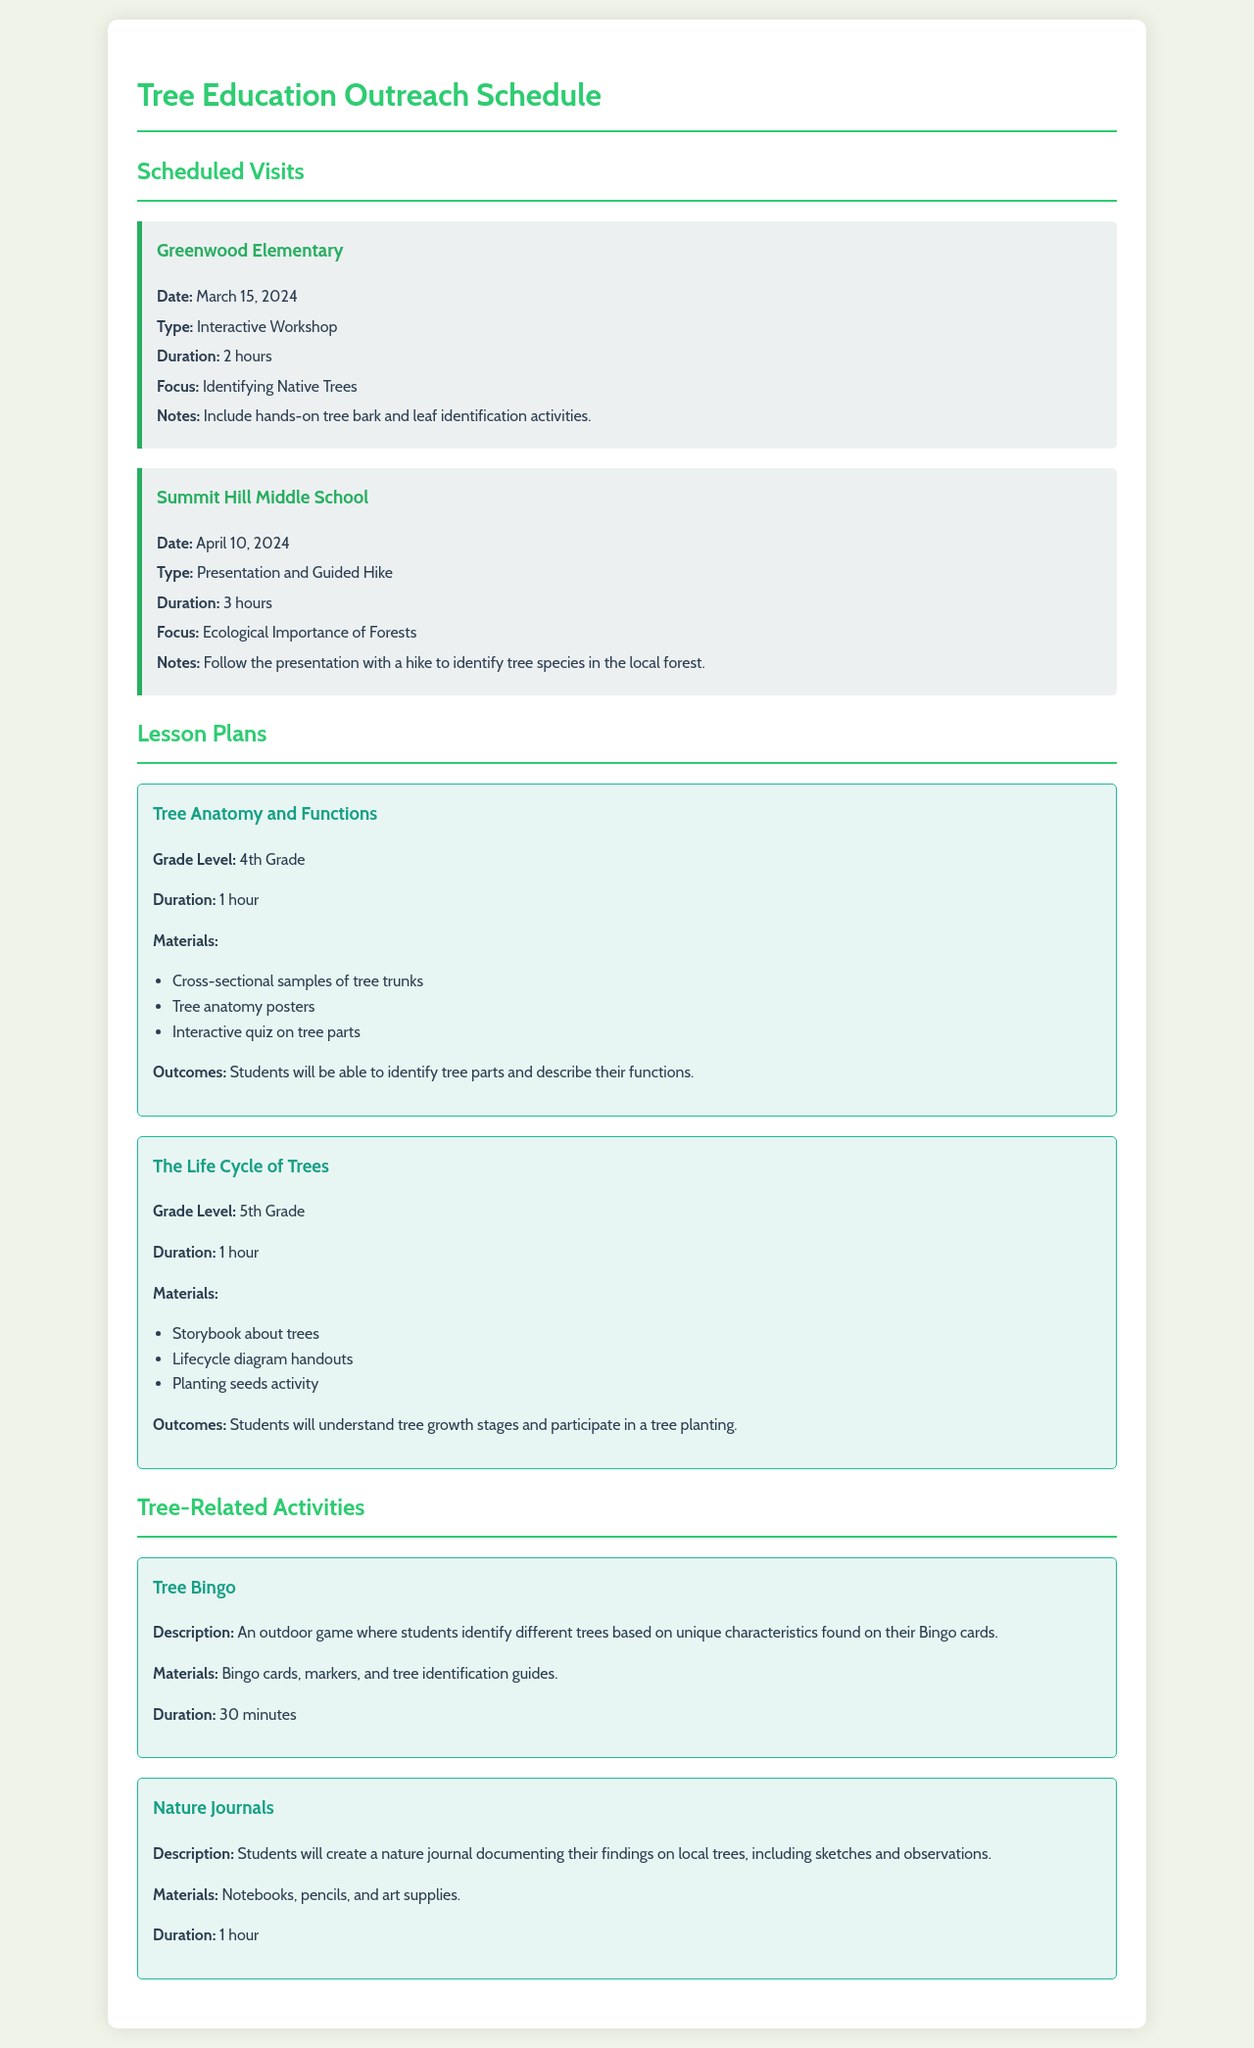what is the date for the Greenwood Elementary visit? The document states that Greenwood Elementary is scheduled for March 15, 2024.
Answer: March 15, 2024 how long is the workshop at Summit Hill Middle School? The duration of the workshop at Summit Hill Middle School is specified as 3 hours.
Answer: 3 hours what is the focus of the lesson plan for 4th grade? The focus of the 4th grade lesson plan is on tree anatomy and functions.
Answer: Tree Anatomy and Functions what materials are needed for the Tree Bingo activity? The materials listed for the Tree Bingo activity include Bingo cards, markers, and tree identification guides.
Answer: Bingo cards, markers, and tree identification guides how many types of scheduled visits are included in the document? There are two scheduled visits detailed in the document: one for Greenwood Elementary and another for Summit Hill Middle School.
Answer: 2 